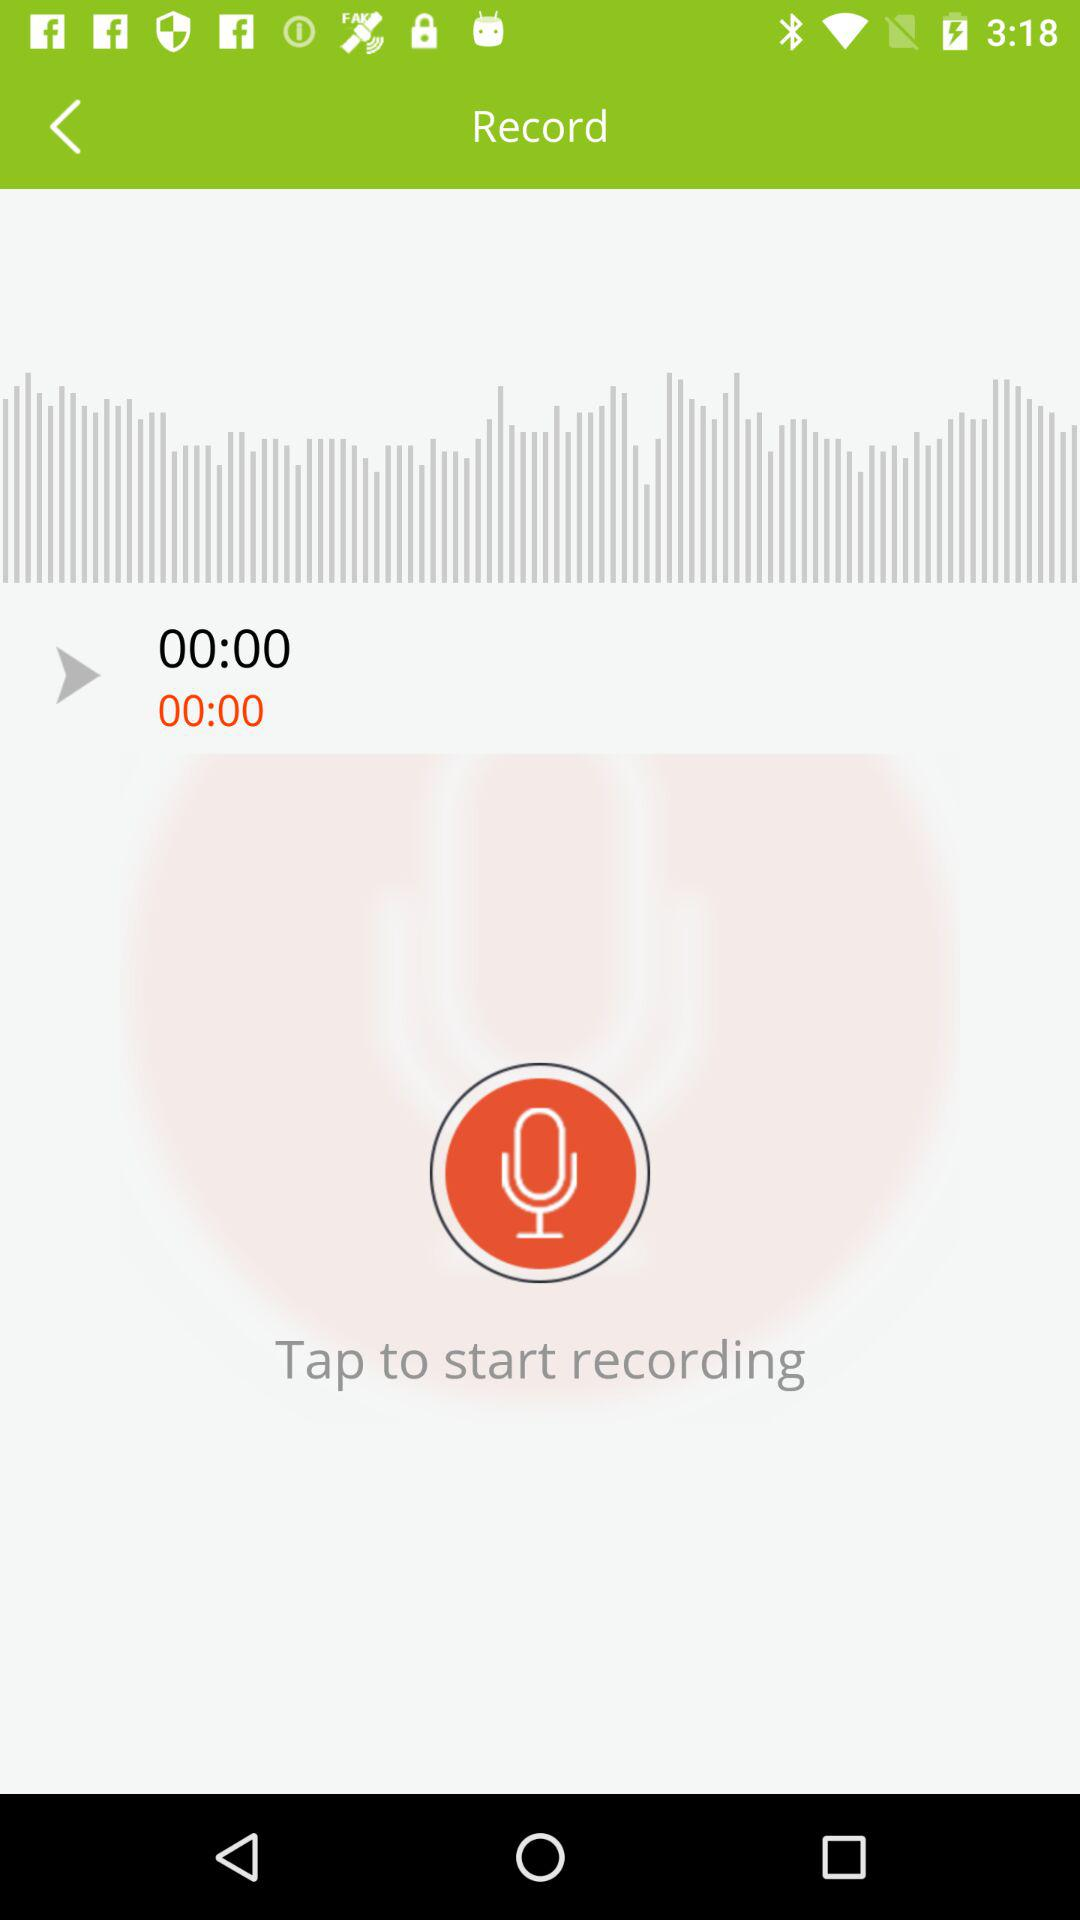How long is the recording?
Answer the question using a single word or phrase. 00:00 